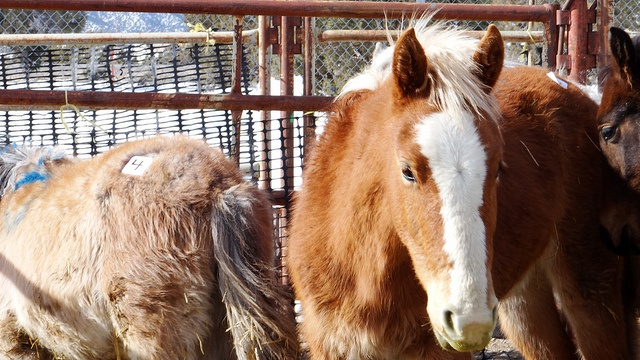Describe the objects in this image and their specific colors. I can see horse in maroon, black, tan, and white tones, horse in maroon, ivory, and tan tones, and horse in maroon, black, brown, and gray tones in this image. 